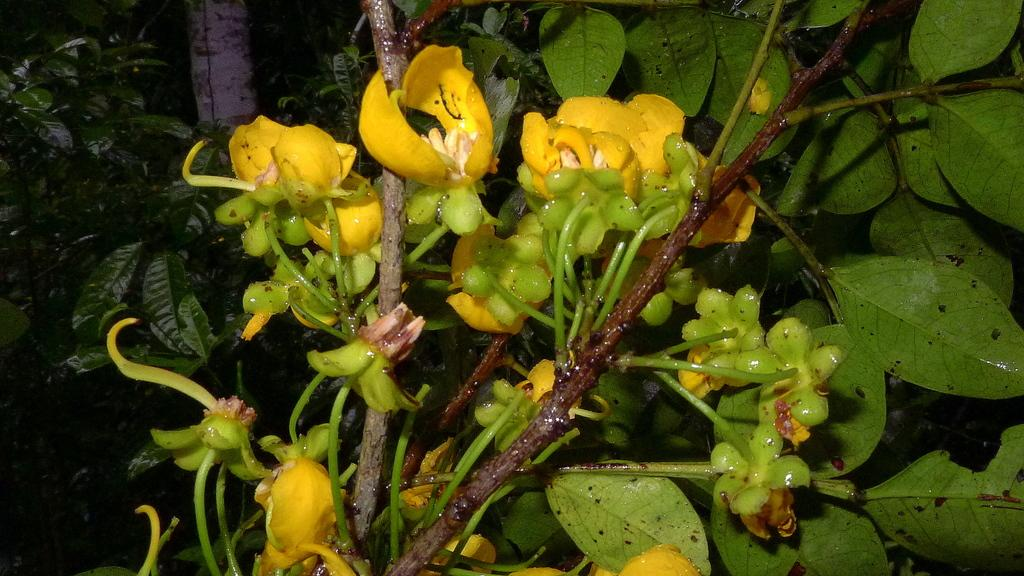What type of plant is present in the image? The image features a plant with flowers. What color are the flowers on the plant? The flowers on the plant are yellow. What type of impulse can be seen affecting the elbow of the honey in the image? There is no impulse, elbow, or honey present in the image. 